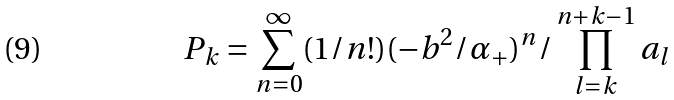<formula> <loc_0><loc_0><loc_500><loc_500>P _ { k } = \sum _ { n = 0 } ^ { \infty } ( 1 / n ! ) ( - b ^ { 2 } / \alpha _ { + } ) ^ { n } / \prod _ { l = k } ^ { n + k - 1 } a _ { l }</formula> 